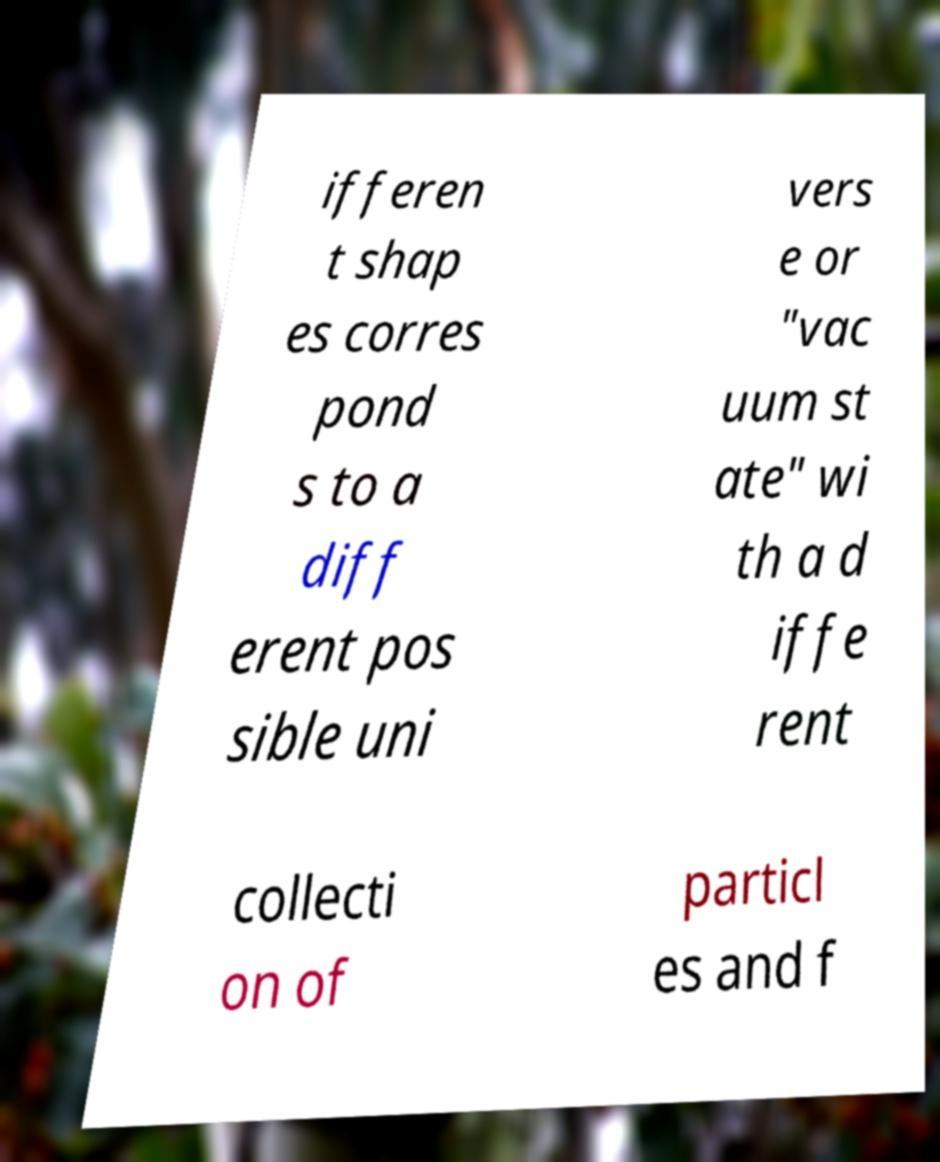I need the written content from this picture converted into text. Can you do that? ifferen t shap es corres pond s to a diff erent pos sible uni vers e or "vac uum st ate" wi th a d iffe rent collecti on of particl es and f 